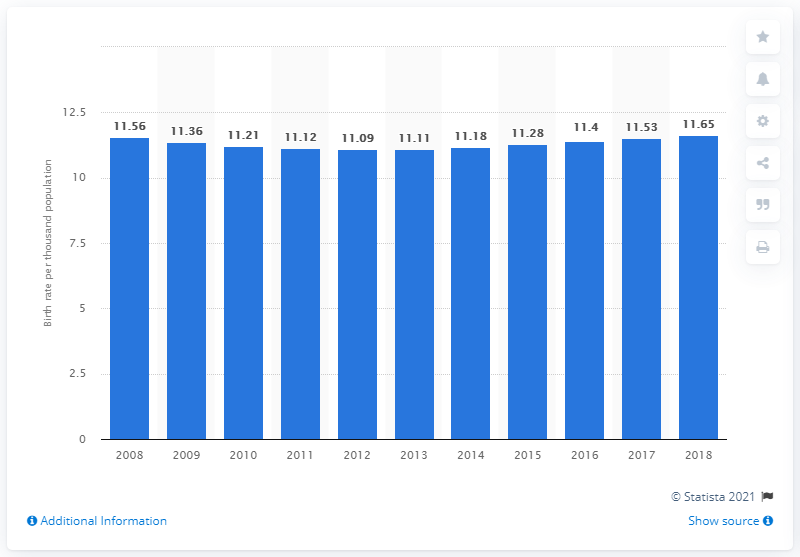Draw attention to some important aspects in this diagram. According to data from 2018, the crude birth rate in Aruba was 11.65. 